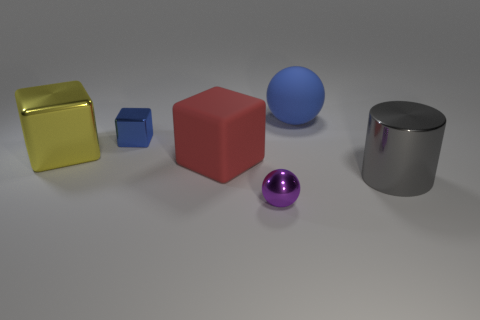Add 4 red metallic balls. How many objects exist? 10 Subtract all spheres. How many objects are left? 4 Subtract all rubber spheres. Subtract all large yellow blocks. How many objects are left? 4 Add 2 tiny purple things. How many tiny purple things are left? 3 Add 6 yellow metal spheres. How many yellow metal spheres exist? 6 Subtract 0 green blocks. How many objects are left? 6 